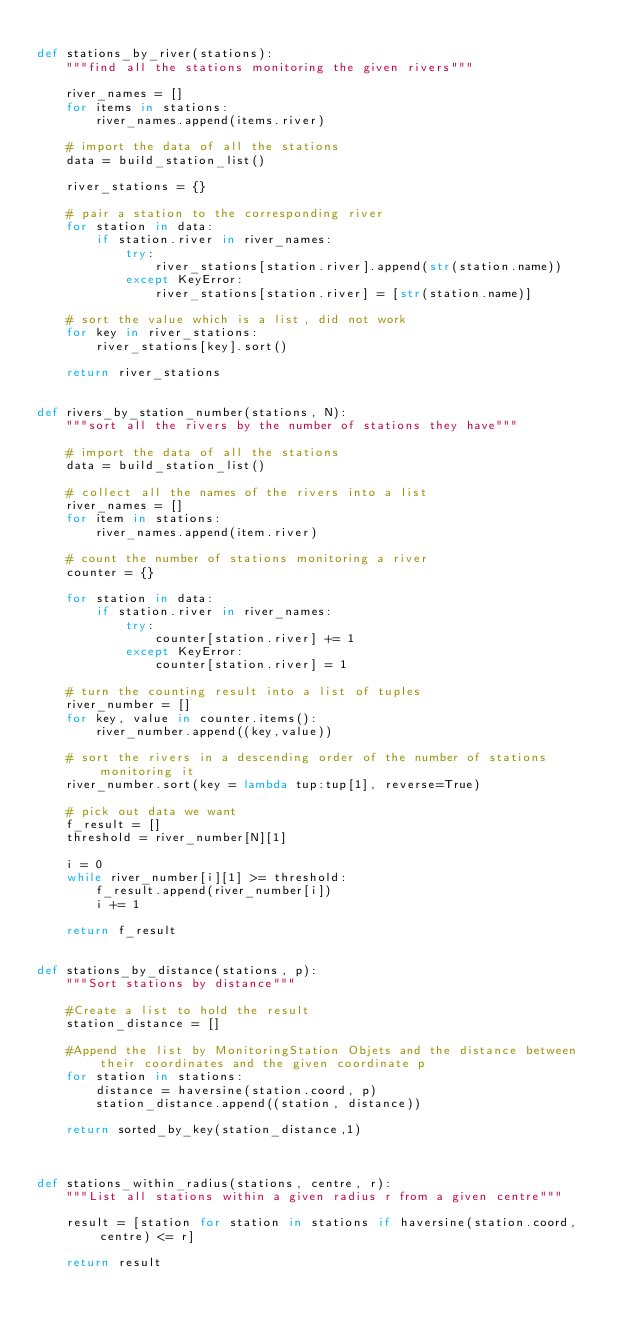<code> <loc_0><loc_0><loc_500><loc_500><_Python_>
def stations_by_river(stations):
    """find all the stations monitoring the given rivers"""

    river_names = []
    for items in stations:
        river_names.append(items.river)

    # import the data of all the stations
    data = build_station_list()

    river_stations = {}

    # pair a station to the corresponding river
    for station in data:
        if station.river in river_names:
            try:
                river_stations[station.river].append(str(station.name))
            except KeyError:
                river_stations[station.river] = [str(station.name)]

    # sort the value which is a list, did not work
    for key in river_stations:
        river_stations[key].sort()

    return river_stations


def rivers_by_station_number(stations, N):
    """sort all the rivers by the number of stations they have"""

    # import the data of all the stations
    data = build_station_list()

    # collect all the names of the rivers into a list
    river_names = []
    for item in stations:
        river_names.append(item.river)

    # count the number of stations monitoring a river
    counter = {}

    for station in data:
        if station.river in river_names:
            try:
                counter[station.river] += 1
            except KeyError:
                counter[station.river] = 1

    # turn the counting result into a list of tuples
    river_number = []
    for key, value in counter.items():
        river_number.append((key,value))

    # sort the rivers in a descending order of the number of stations monitoring it
    river_number.sort(key = lambda tup:tup[1], reverse=True)

    # pick out data we want
    f_result = []
    threshold = river_number[N][1]

    i = 0
    while river_number[i][1] >= threshold:
        f_result.append(river_number[i])
        i += 1

    return f_result


def stations_by_distance(stations, p):
    """Sort stations by distance"""

    #Create a list to hold the result
    station_distance = []
    
    #Append the list by MonitoringStation Objets and the distance between their coordinates and the given coordinate p
    for station in stations:
        distance = haversine(station.coord, p)
        station_distance.append((station, distance))
        
    return sorted_by_key(station_distance,1)

    

def stations_within_radius(stations, centre, r):
    """List all stations within a given radius r from a given centre"""

    result = [station for station in stations if haversine(station.coord, centre) <= r]
        
    return result
</code> 